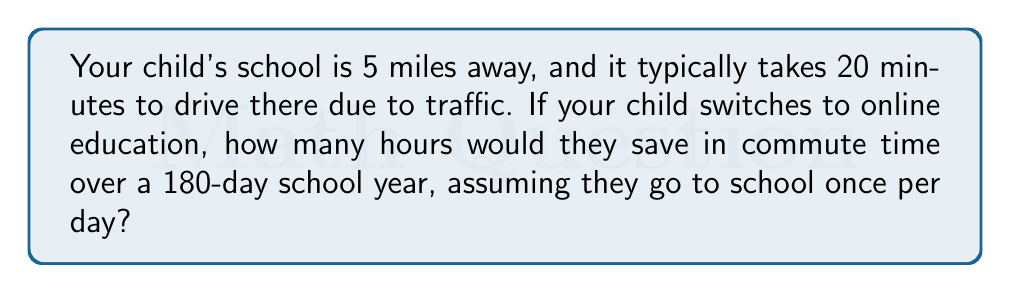What is the answer to this math problem? Let's break this down step-by-step:

1. Calculate the daily commute time:
   - Each school day requires a round trip (to school and back)
   - Time for one-way trip = 20 minutes
   - Daily commute time = $20 \times 2 = 40$ minutes

2. Calculate the total commute time for the school year:
   - Number of school days = 180
   - Total commute time = Daily commute time $\times$ Number of school days
   - Total commute time = $40 \times 180 = 7200$ minutes

3. Convert minutes to hours:
   - $1$ hour = $60$ minutes
   - Hours saved = $\frac{\text{Total minutes}}{60}$
   - Hours saved = $\frac{7200}{60} = 120$ hours

Therefore, by switching to online education, your child would save 120 hours in commute time over the course of a 180-day school year.
Answer: 120 hours 